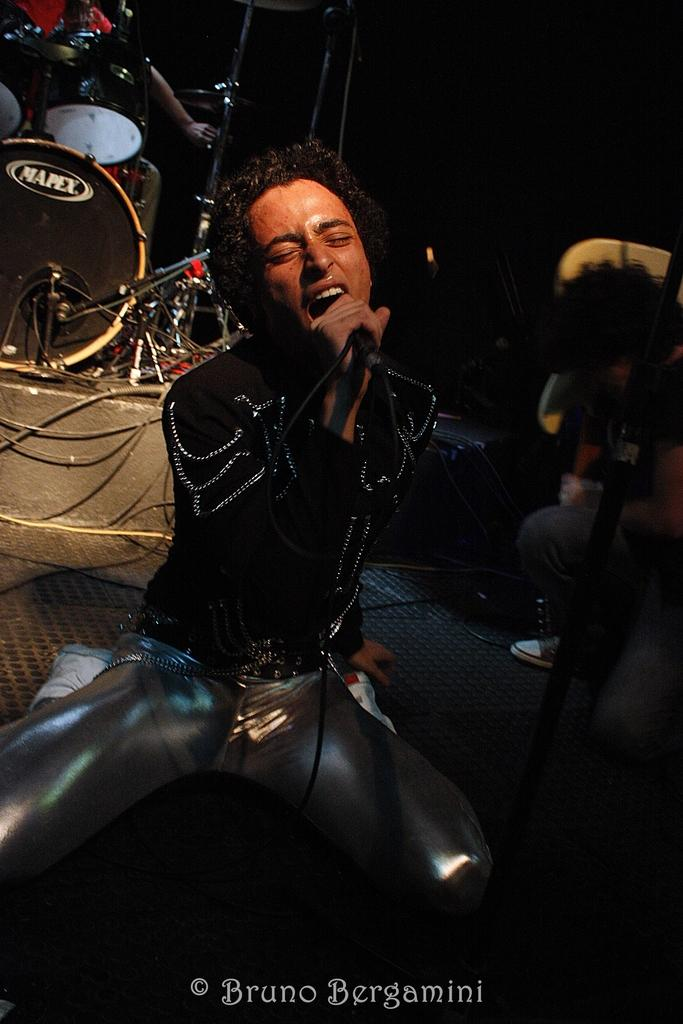Who is the main subject in the image? There is a man in the image. What is the man doing in the image? The man is sitting on the floor and singing on a microphone. What can be seen in the background of the image? There are musical instruments in the background of the image. What type of garden can be seen in the image? There is no garden present in the image; it features a man sitting on the floor and singing on a microphone with musical instruments in the background. 